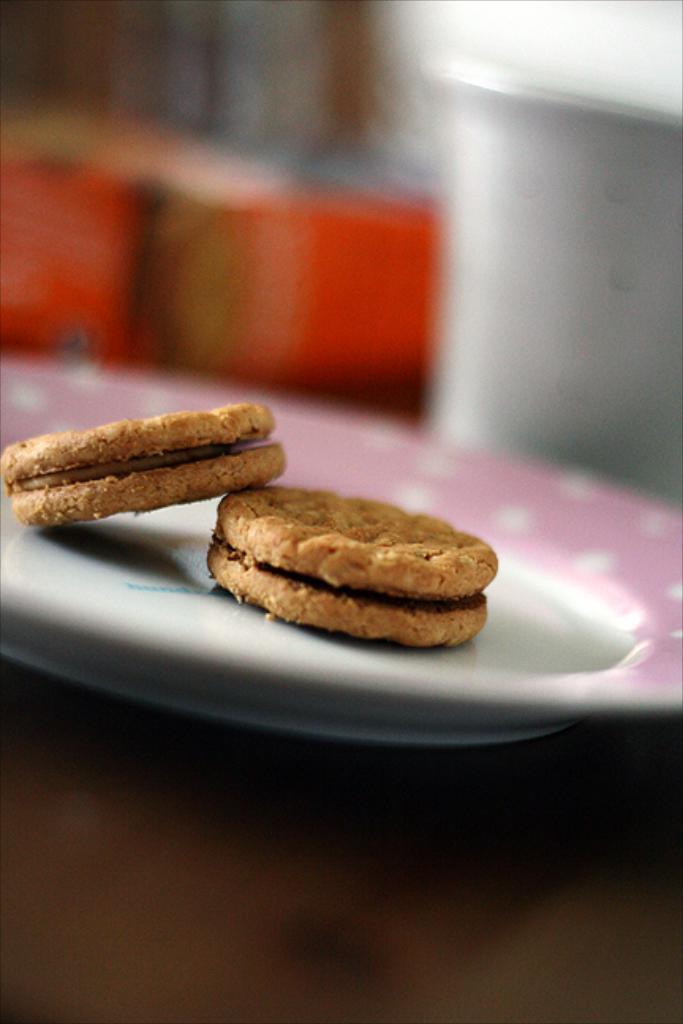Can you describe this image briefly? In the center of the image there is a table. On the table we can see cookies on a plate, glass and some objects. In the background the image is blur. 